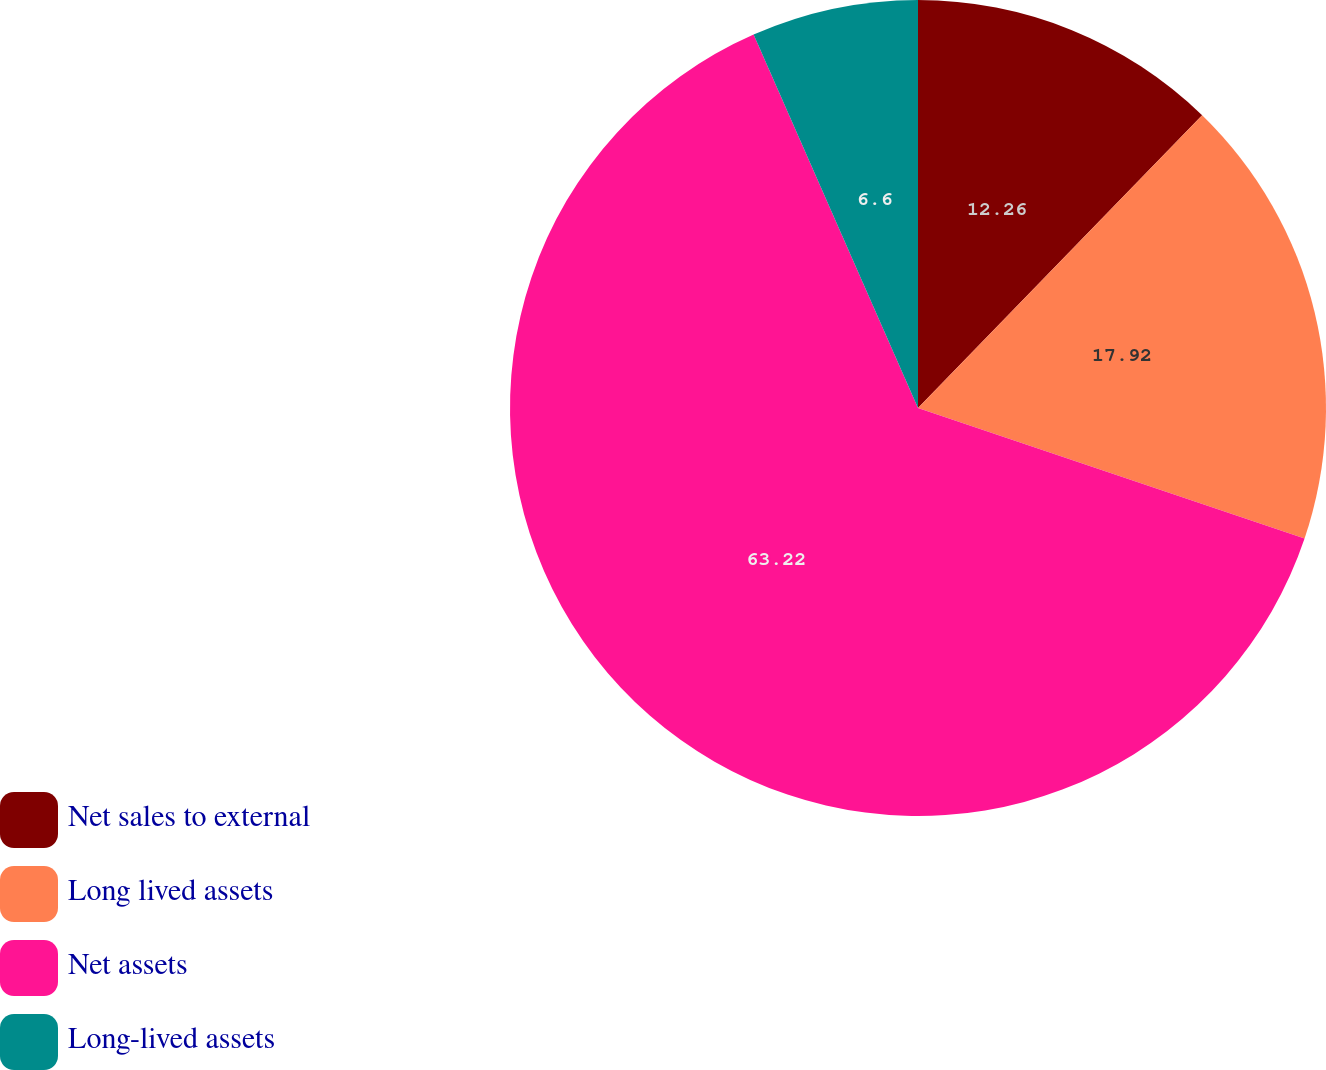Convert chart. <chart><loc_0><loc_0><loc_500><loc_500><pie_chart><fcel>Net sales to external<fcel>Long lived assets<fcel>Net assets<fcel>Long-lived assets<nl><fcel>12.26%<fcel>17.92%<fcel>63.21%<fcel>6.6%<nl></chart> 